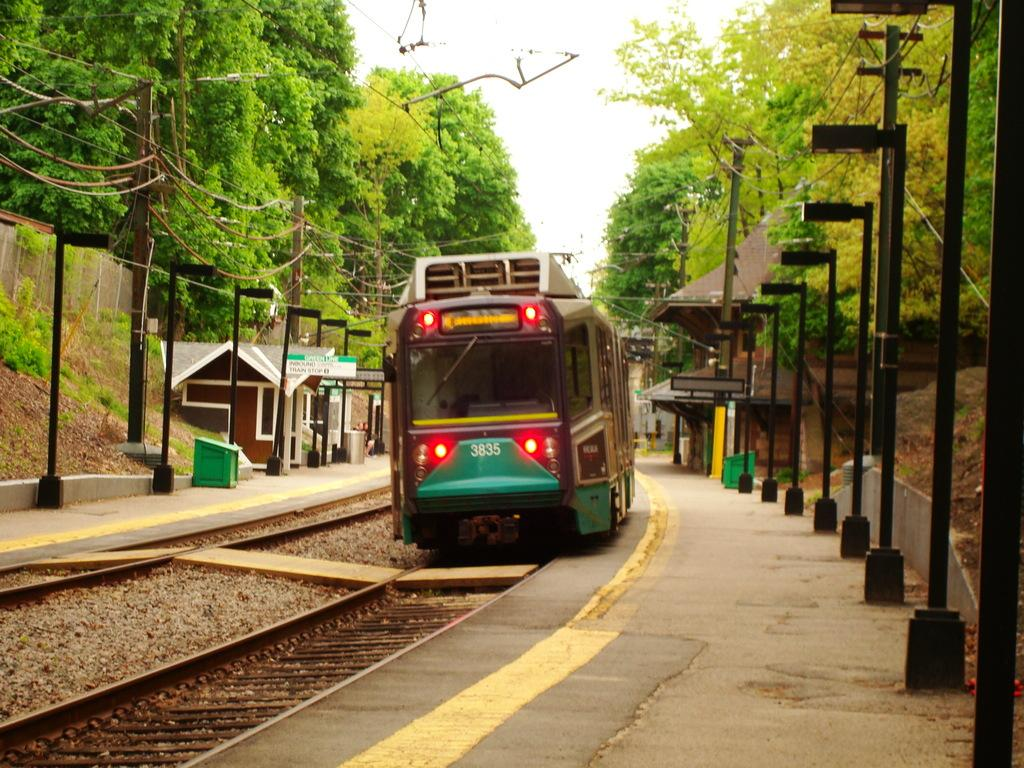What is the main subject of the image? The main subject of the image is a train. Where is the train located in relation to the poles? The train is between poles in the image. What type of vegetation can be seen in the top left and top right of the image? There are trees in the top left and top right of the image. What is visible at the top of the image? The sky is visible at the top of the image. How many chalk pieces are scattered on the train tracks in the image? There are no chalk pieces visible on the train tracks in the image. What type of plantation can be seen in the background of the image? There is no plantation present in the image; it features a train between poles with trees and sky visible. 